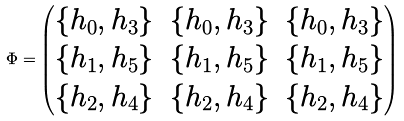<formula> <loc_0><loc_0><loc_500><loc_500>\Phi = \begin{pmatrix} \{ h _ { 0 } , h _ { 3 } \} & \{ h _ { 0 } , h _ { 3 } \} & \{ h _ { 0 } , h _ { 3 } \} \\ \{ h _ { 1 } , h _ { 5 } \} & \{ h _ { 1 } , h _ { 5 } \} & \{ h _ { 1 } , h _ { 5 } \} \\ \{ h _ { 2 } , h _ { 4 } \} & \{ h _ { 2 } , h _ { 4 } \} & \{ h _ { 2 } , h _ { 4 } \} \\ \end{pmatrix}</formula> 